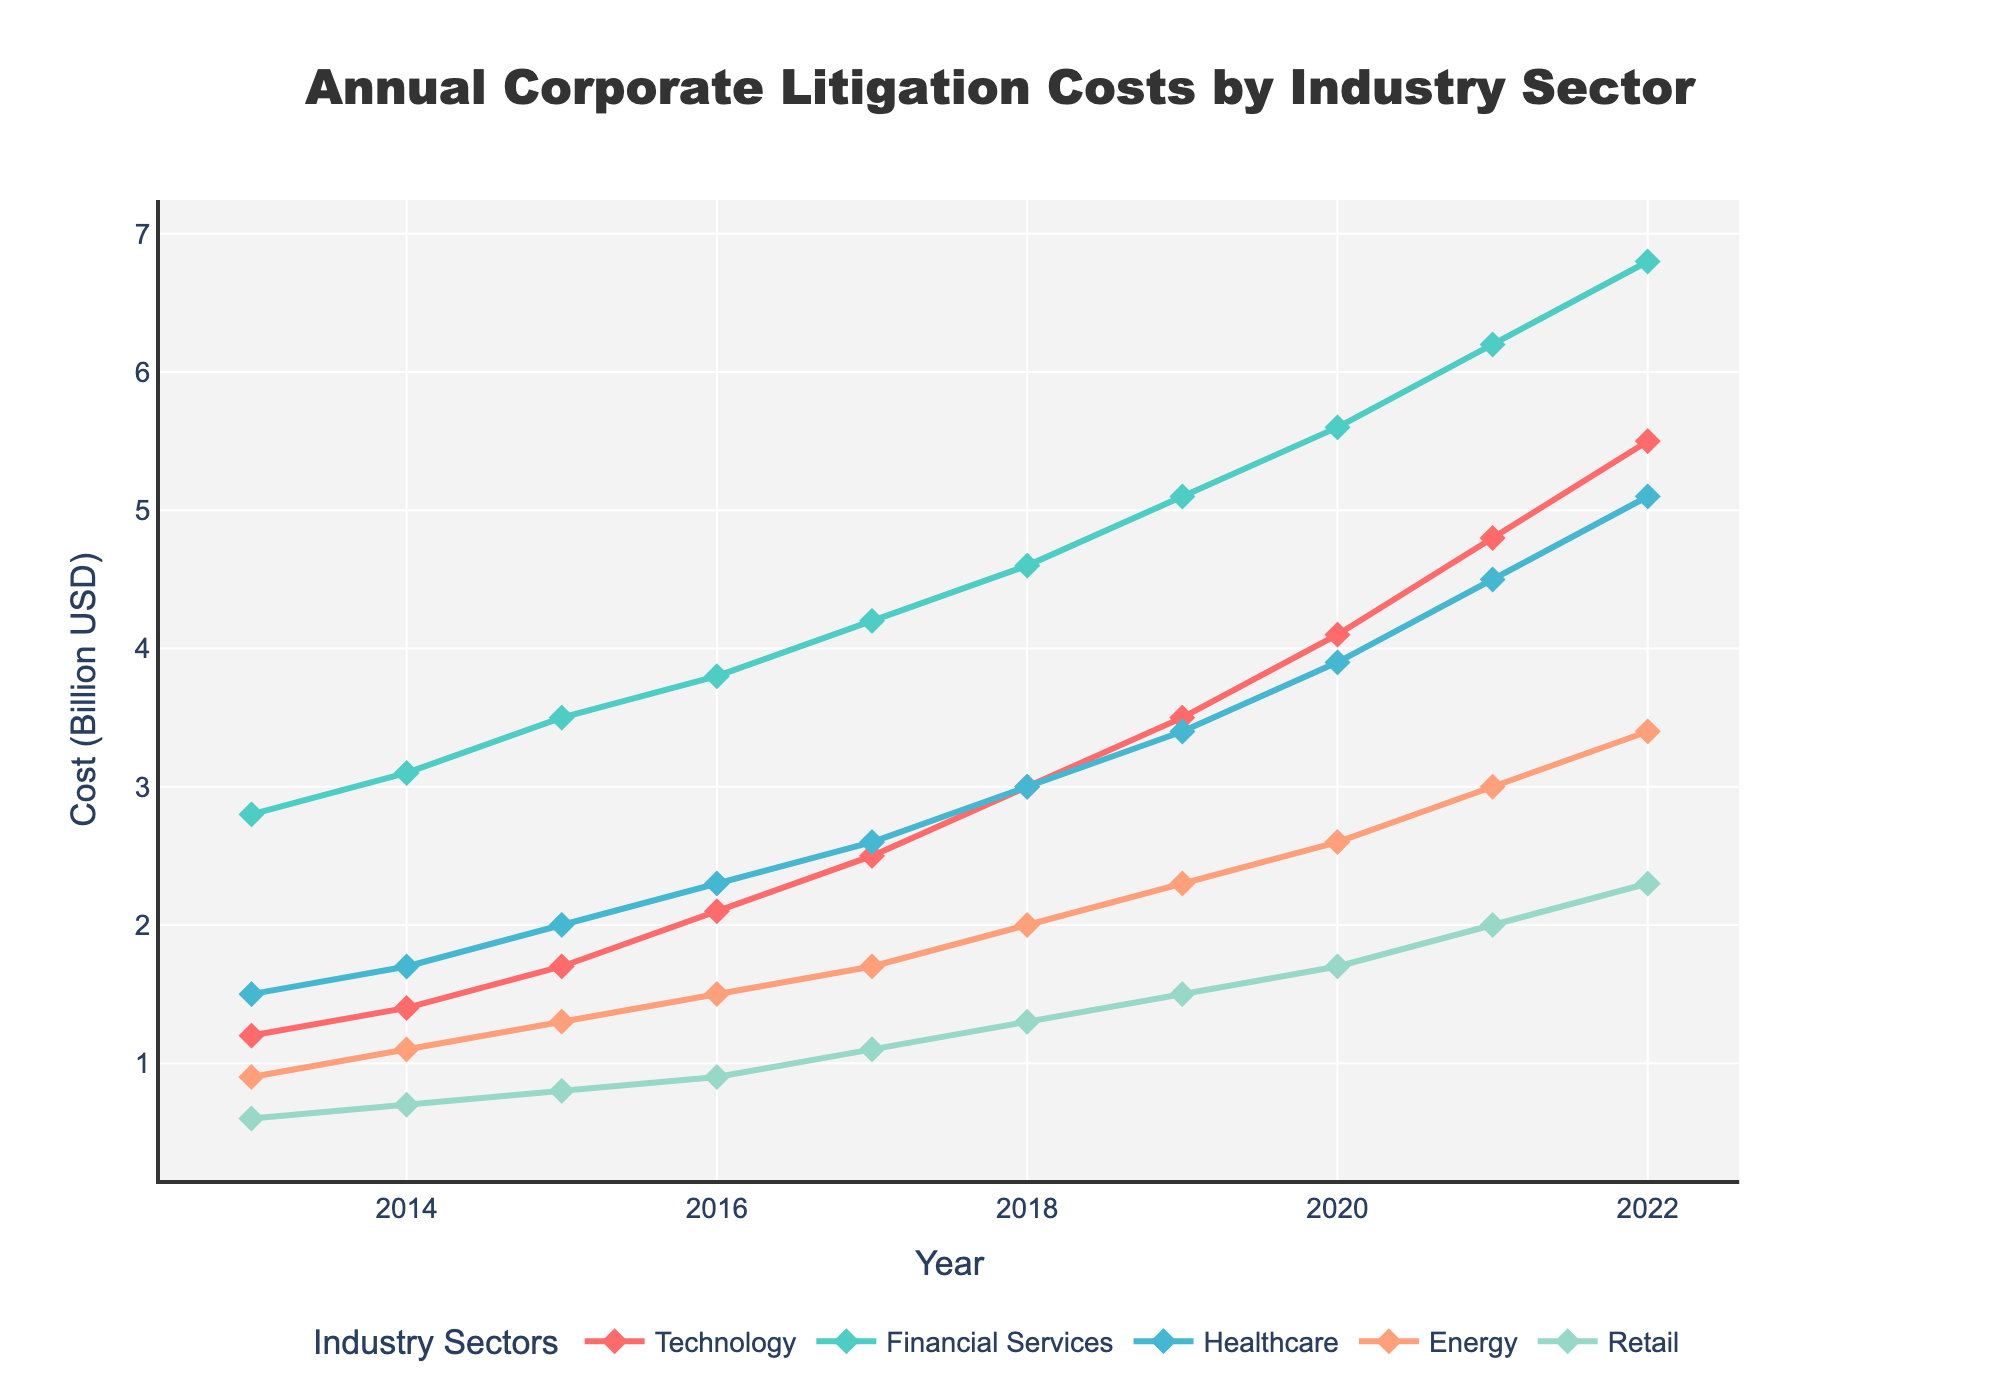What's the overall trend in litigation costs for the Technology sector over the past decade? The figure shows that the litigation costs for the Technology sector increase steadily each year from 2013 to 2022, rising from 1.2 billion USD to 5.5 billion USD.
Answer: Rising Which industry sector had the highest litigation costs in 2022? According to the figure, the Financial Services sector had the highest litigation costs in 2022, with costs amounting to 6.8 billion USD.
Answer: Financial Services By how much did the litigation costs for Healthcare increase from 2013 to 2022? The litigation costs for Healthcare were 1.5 billion USD in 2013 and increased to 5.1 billion USD in 2022. The increase is calculated as 5.1 - 1.5 = 3.6 billion USD.
Answer: 3.6 billion USD Which two sectors had the smallest difference in litigation costs in 2016? From the figure, the litigation costs in 2016 were: Financial Services (3.8 billion USD), Technology (2.1 billion USD), Healthcare (2.3 billion USD), Energy (1.5 billion USD), and Retail (0.9 billion USD). The closest values are for Technology (2.1 billion USD) and Healthcare (2.3 billion USD), with a difference of 0.2 billion USD.
Answer: Technology and Healthcare What is the average litigation cost for the Energy sector from 2013 to 2017? The litigation costs for the Energy sector from 2013 to 2017 are 0.9, 1.1, 1.3, 1.5, and 1.7 billion USD. The average is calculated as (0.9 + 1.1 + 1.3 + 1.5 + 1.7) / 5 = 6.5 / 5 = 1.3 billion USD.
Answer: 1.3 billion USD How much did the litigation costs for the Financial Services sector change from 2018 to 2019? In 2018, the litigation costs for Financial Services were 4.6 billion USD and in 2019, they were 5.1 billion USD. The change is calculated as 5.1 - 4.6 = 0.5 billion USD.
Answer: 0.5 billion USD Which industry sectors have litigation costs that intersect at any point? The figure shows that the litigation costs of Technology and Healthcare sectors intersected around 2013 when both were close to 1.2 - 1.5 billion USD.
Answer: Technology and Healthcare What is the median litigation cost for Retail sector data from 2013 to 2022? The costs for Retail from 2013 to 2022 are: 0.6, 0.7, 0.8, 0.9, 1.1, 1.3, 1.5, 1.7, 2.0, and 2.3 billion USD. Arranging these values in ascending order, the middle values (median) are 1.1 and 1.3; therefore, the median is (1.1 + 1.3) / 2 = 1.2 billion USD.
Answer: 1.2 billion USD What color is used to represent the Energy sector? The figure uses orange to represent the Energy sector.
Answer: Orange 